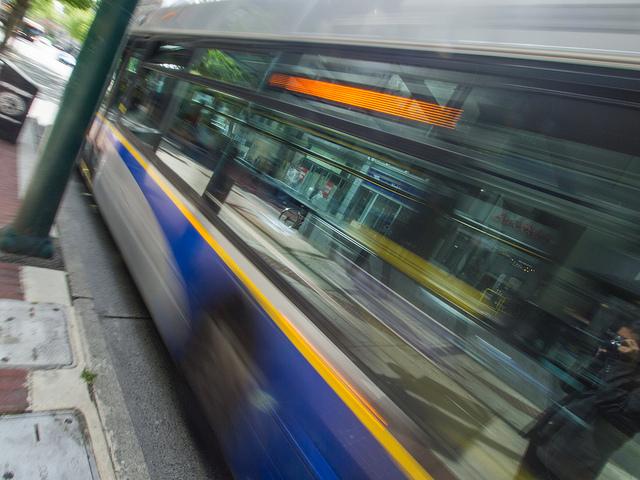Is the picture clear?
Be succinct. No. What in on the road?
Keep it brief. Bus. Is this a subway or bus?
Answer briefly. Bus. 